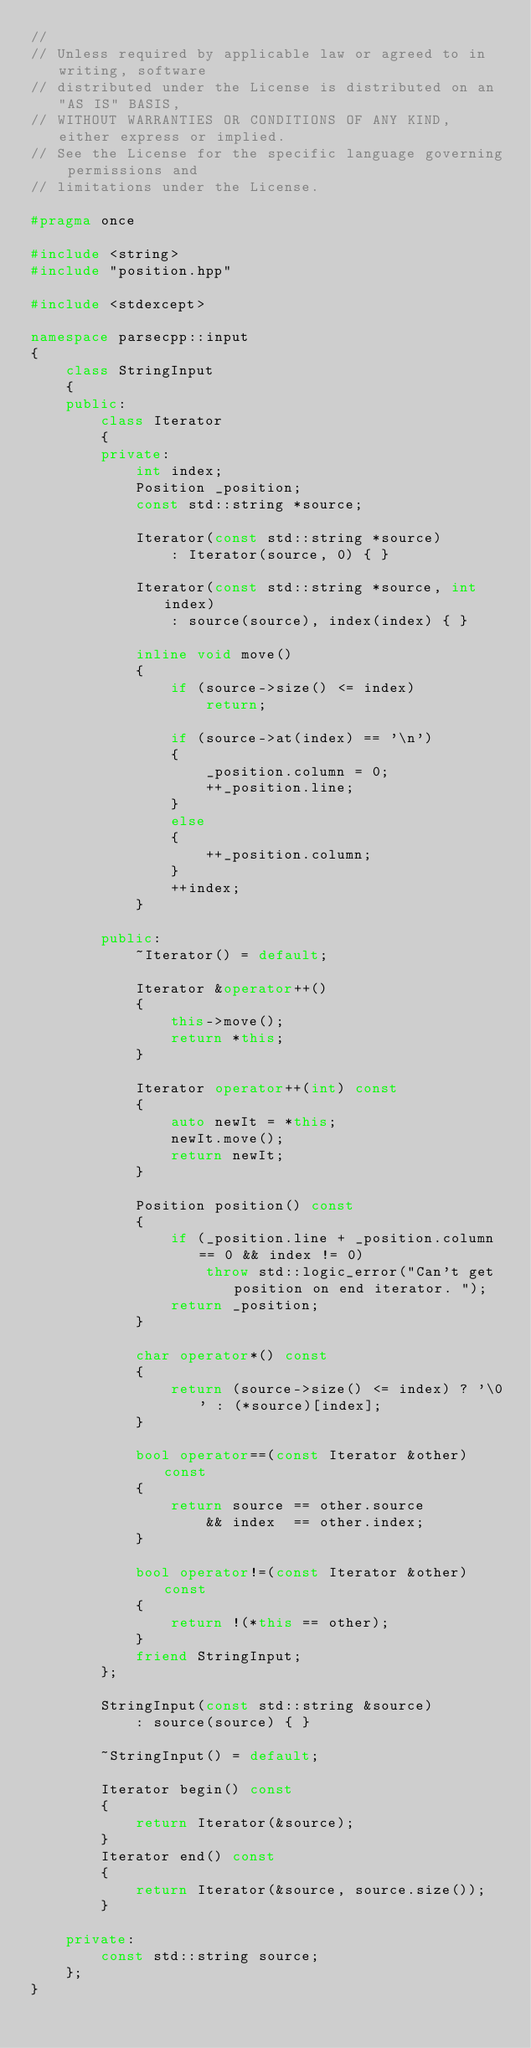<code> <loc_0><loc_0><loc_500><loc_500><_C++_>// 
// Unless required by applicable law or agreed to in writing, software
// distributed under the License is distributed on an "AS IS" BASIS,
// WITHOUT WARRANTIES OR CONDITIONS OF ANY KIND, either express or implied.
// See the License for the specific language governing permissions and
// limitations under the License.

#pragma once

#include <string>
#include "position.hpp"

#include <stdexcept>

namespace parsecpp::input
{
    class StringInput
    {
    public:
        class Iterator
        {
        private:
            int index;
            Position _position;
            const std::string *source;

            Iterator(const std::string *source)
                : Iterator(source, 0) { }

            Iterator(const std::string *source, int index)
                : source(source), index(index) { }

            inline void move()
            {
                if (source->size() <= index)
                    return;

                if (source->at(index) == '\n')
                {
                    _position.column = 0;
                    ++_position.line;
                }
                else
                {
                    ++_position.column;
                }
                ++index;        
            }

        public:
            ~Iterator() = default;

            Iterator &operator++()
            {
                this->move();
                return *this;
            }

            Iterator operator++(int) const
            {
                auto newIt = *this;
                newIt.move();
                return newIt;
            }

            Position position() const
            {
                if (_position.line + _position.column == 0 && index != 0)
                    throw std::logic_error("Can't get position on end iterator. ");
                return _position;
            }

            char operator*() const
            {
                return (source->size() <= index) ? '\0' : (*source)[index];
            }

            bool operator==(const Iterator &other) const
            {
                return source == other.source
                    && index  == other.index;
            }

            bool operator!=(const Iterator &other) const
            {
                return !(*this == other);
            }
            friend StringInput;
        };

        StringInput(const std::string &source)
            : source(source) { }

        ~StringInput() = default;

        Iterator begin() const
        {
            return Iterator(&source);
        }
        Iterator end() const
        {
            return Iterator(&source, source.size());
        }

    private:
        const std::string source;
    };
}
</code> 